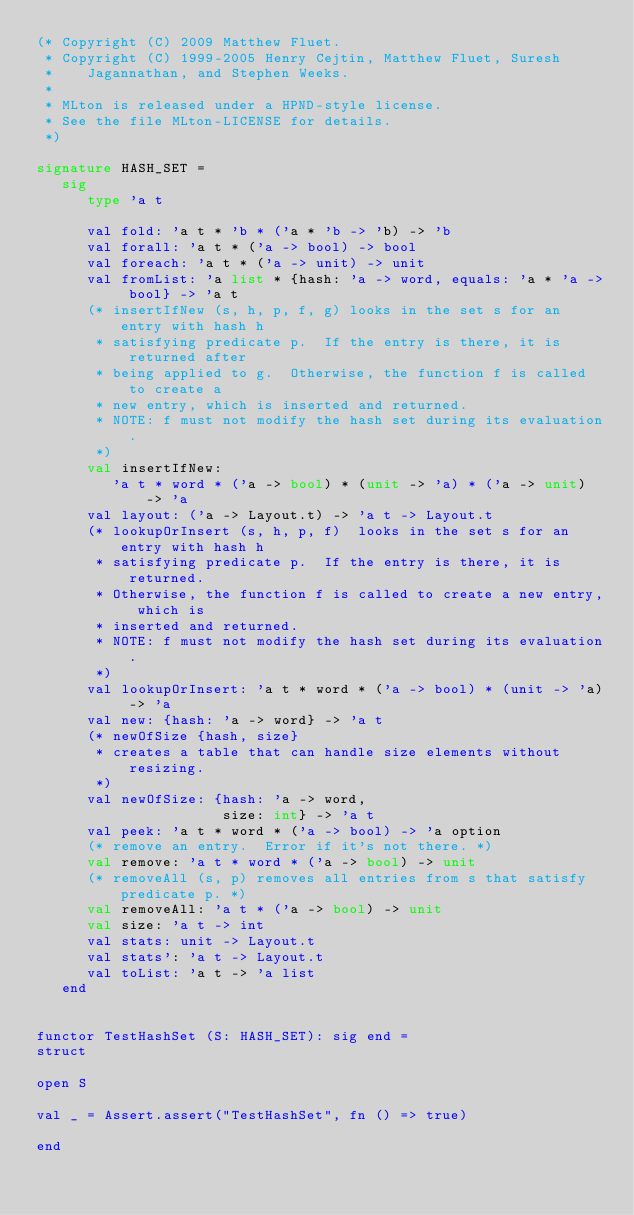<code> <loc_0><loc_0><loc_500><loc_500><_SML_>(* Copyright (C) 2009 Matthew Fluet.
 * Copyright (C) 1999-2005 Henry Cejtin, Matthew Fluet, Suresh
 *    Jagannathan, and Stephen Weeks.
 *
 * MLton is released under a HPND-style license.
 * See the file MLton-LICENSE for details.
 *)

signature HASH_SET =
   sig
      type 'a t

      val fold: 'a t * 'b * ('a * 'b -> 'b) -> 'b
      val forall: 'a t * ('a -> bool) -> bool
      val foreach: 'a t * ('a -> unit) -> unit
      val fromList: 'a list * {hash: 'a -> word, equals: 'a * 'a -> bool} -> 'a t
      (* insertIfNew (s, h, p, f, g) looks in the set s for an entry with hash h
       * satisfying predicate p.  If the entry is there, it is returned after
       * being applied to g.  Otherwise, the function f is called to create a
       * new entry, which is inserted and returned.
       * NOTE: f must not modify the hash set during its evaluation.
       *)
      val insertIfNew:
         'a t * word * ('a -> bool) * (unit -> 'a) * ('a -> unit) -> 'a
      val layout: ('a -> Layout.t) -> 'a t -> Layout.t
      (* lookupOrInsert (s, h, p, f)  looks in the set s for an entry with hash h
       * satisfying predicate p.  If the entry is there, it is returned.
       * Otherwise, the function f is called to create a new entry, which is
       * inserted and returned.
       * NOTE: f must not modify the hash set during its evaluation.
       *)
      val lookupOrInsert: 'a t * word * ('a -> bool) * (unit -> 'a) -> 'a
      val new: {hash: 'a -> word} -> 'a t
      (* newOfSize {hash, size}
       * creates a table that can handle size elements without resizing.
       *)
      val newOfSize: {hash: 'a -> word,
                      size: int} -> 'a t
      val peek: 'a t * word * ('a -> bool) -> 'a option
      (* remove an entry.  Error if it's not there. *)
      val remove: 'a t * word * ('a -> bool) -> unit
      (* removeAll (s, p) removes all entries from s that satisfy predicate p. *)
      val removeAll: 'a t * ('a -> bool) -> unit
      val size: 'a t -> int
      val stats: unit -> Layout.t
      val stats': 'a t -> Layout.t
      val toList: 'a t -> 'a list
   end


functor TestHashSet (S: HASH_SET): sig end =
struct

open S

val _ = Assert.assert("TestHashSet", fn () => true)

end
</code> 